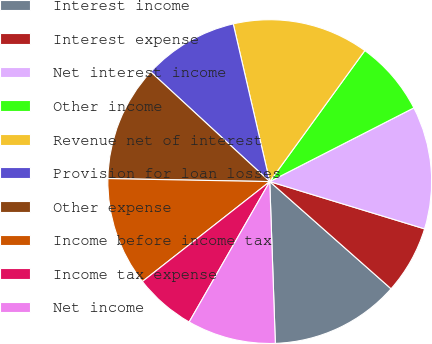Convert chart to OTSL. <chart><loc_0><loc_0><loc_500><loc_500><pie_chart><fcel>Interest income<fcel>Interest expense<fcel>Net interest income<fcel>Other income<fcel>Revenue net of interest<fcel>Provision for loan losses<fcel>Other expense<fcel>Income before income tax<fcel>Income tax expense<fcel>Net income<nl><fcel>12.93%<fcel>6.8%<fcel>12.24%<fcel>7.48%<fcel>13.61%<fcel>9.52%<fcel>11.56%<fcel>10.88%<fcel>6.12%<fcel>8.84%<nl></chart> 